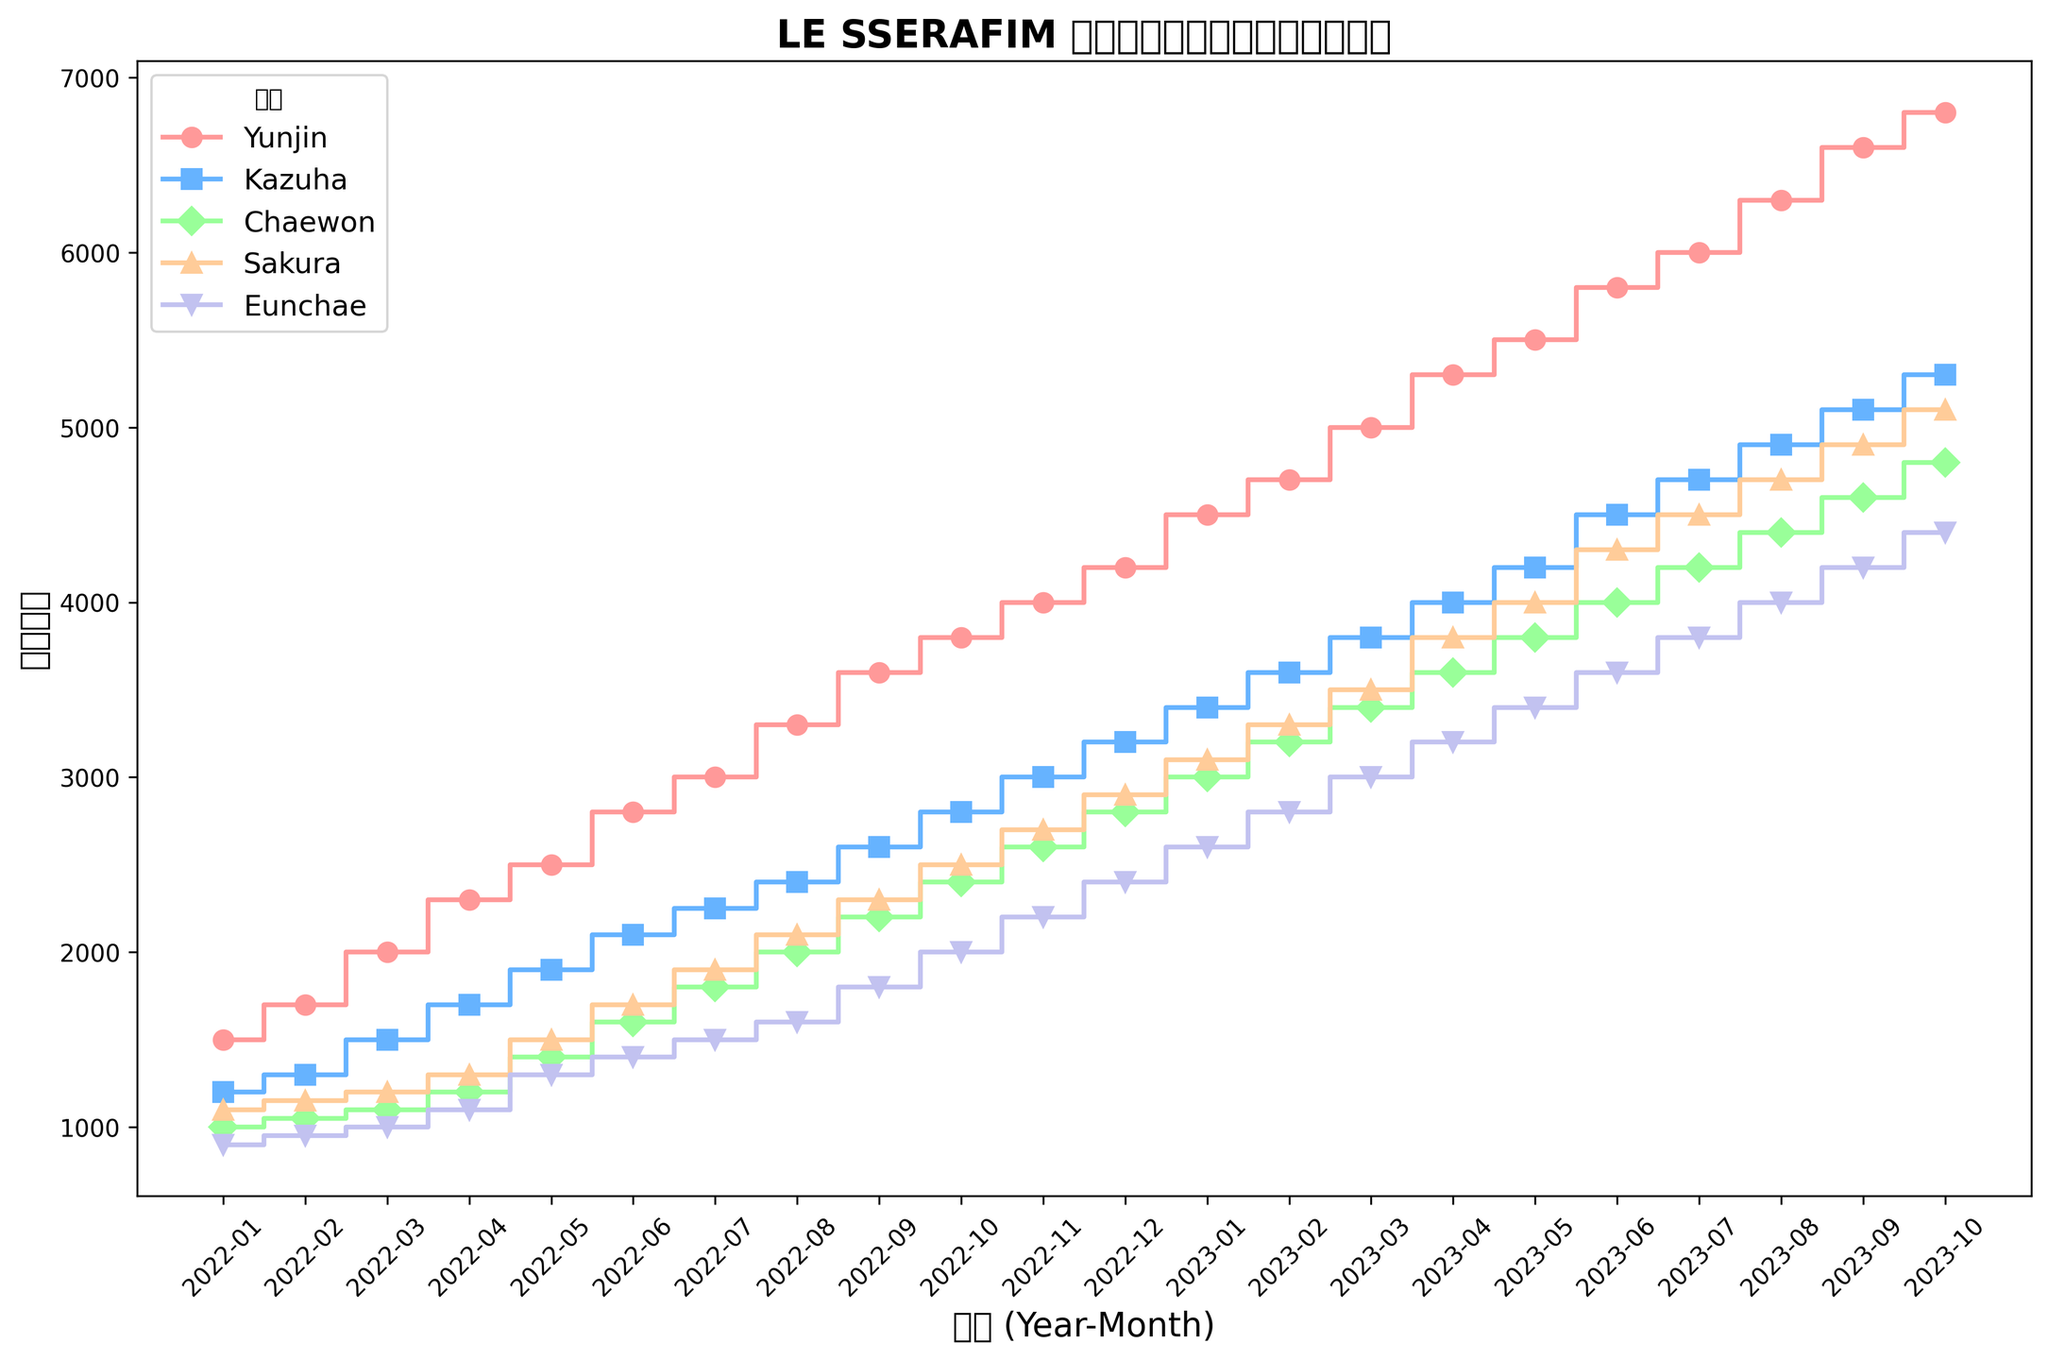哪个成员在2023年8月拥有最多粉丝？ 查看图中2023年8月的数据点，找到最大的数值并对应相应的成员。Yunjin 在2023年8月拥有最高的粉丝数，为6300。
Answer: Yunjin 在2023年4月，Kazuha 的粉丝数是多少？ 查看图中2023年4月的 Kazuha 数据点，即图中日期为2023-04的Kazuha数据。Kazuha在2023年4月有4000粉丝。
Answer: 4000 Sakura和Chaewon在2023年1月的粉丝之和是多少？ 查看图中2023年1月的Sakura和Chaewon数据点，然后将它们相加。Sakura在2023年1月有3100粉丝，Chaewon有3000粉丝，合计为6100。
Answer: 6100 从2022年1月到2023年10月，哪个成员的粉丝增长最显著？ 检查每个成员从2022年1月到2023年10月的粉丝数变化。Yunjin从1500增长到6800，增长了5300，为所有成员中增长最多的。
Answer: Yunjin 2022年4月哪个成员的粉丝数最低？ 查看图中2022年4月的数据点，找出最小的数值并对应相应的成员。Eunchae在2022年4月的粉丝数为最低，为1100。
Answer: Eunchae Eunchae在2022年11月和2023年4月的粉丝数之和是多少？ 查看图中2022年11月和2023年4月的Eunchae数据点，然后将它们相加。Eunchae在2022年11月有2200粉丝，在2023年4月有3200粉丝，合计为5400。
Answer: 5400 哪位成员在2022年7月和2023年7月之间的增幅最大？ 分别计算每个成员2022年7月至2023年7月的粉丝增长量，通过比较找到最大的值。Yunjin从3000增至6000，增幅最大，为3000。
Answer: Yunjin 从图中可以看出哪个成员在2023年10月粉丝数最高？ 查看图中2023年10月的数据点，找到数值最大的成员。Yunjin在2023年10月的粉丝数最高，为6800。
Answer: Yunjin 